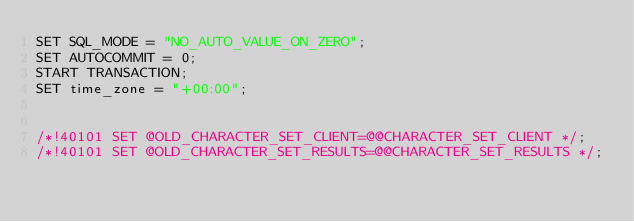<code> <loc_0><loc_0><loc_500><loc_500><_SQL_>SET SQL_MODE = "NO_AUTO_VALUE_ON_ZERO";
SET AUTOCOMMIT = 0;
START TRANSACTION;
SET time_zone = "+00:00";


/*!40101 SET @OLD_CHARACTER_SET_CLIENT=@@CHARACTER_SET_CLIENT */;
/*!40101 SET @OLD_CHARACTER_SET_RESULTS=@@CHARACTER_SET_RESULTS */;</code> 